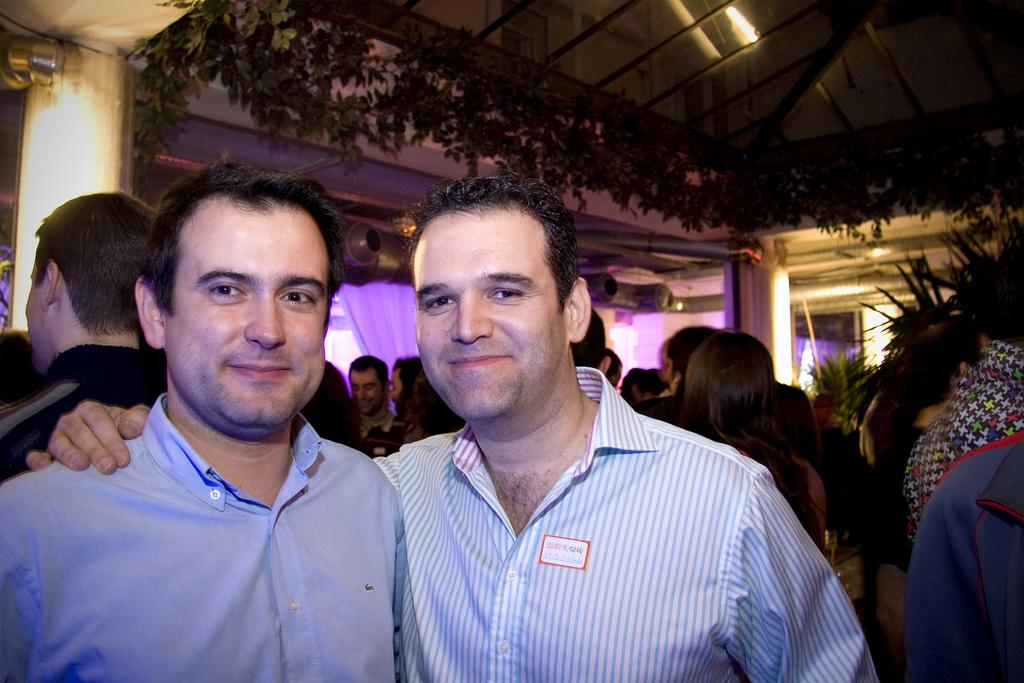How many men are present in the image? There are two men in the image. Can you describe the background of the image? In the background of the image, there are lights, pillars, curtains, plants, a glass roof, poles, and other objects. Are there any other people visible in the image besides the two men? Yes, there are few persons in the background of the image. What decision did the creator of the image make regarding the inclusion of the aunt in the image? There is no mention of an aunt or a creator in the image or the provided facts, so it is not possible to answer this question. 